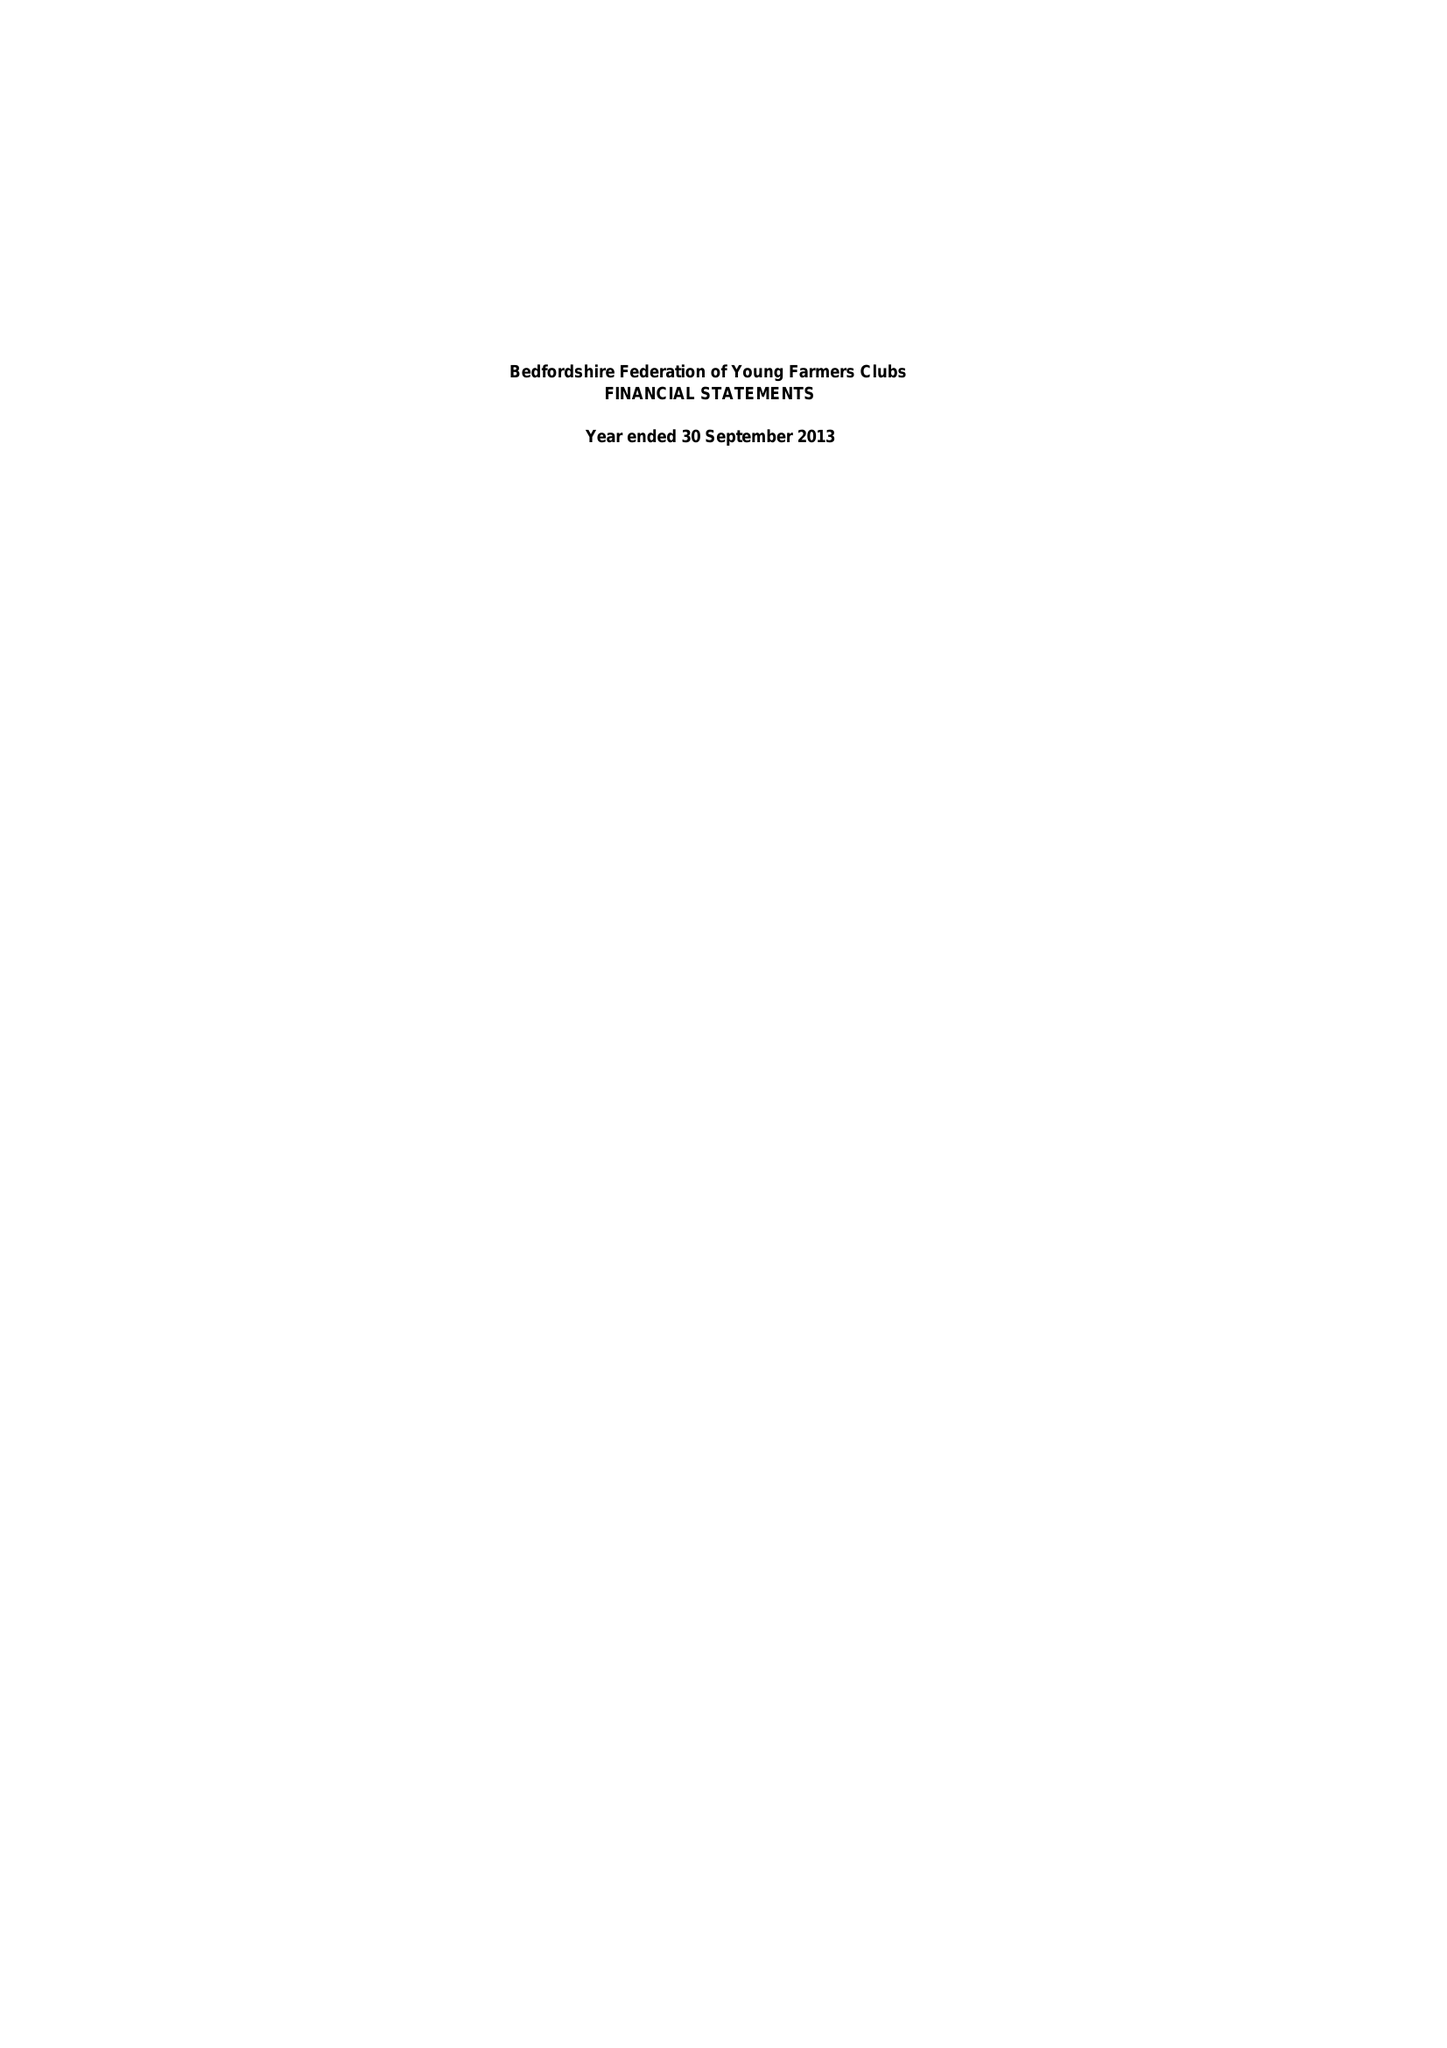What is the value for the report_date?
Answer the question using a single word or phrase. 2013-09-30 